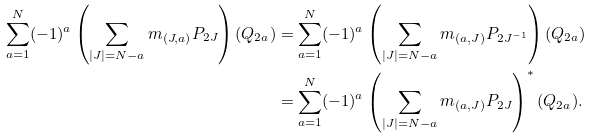Convert formula to latex. <formula><loc_0><loc_0><loc_500><loc_500>\sum _ { a = 1 } ^ { N } ( - 1 ) ^ { a } \left ( \sum _ { | J | = N - a } m _ { ( J , a ) } P _ { 2 J } \right ) ( Q _ { 2 a } ) & = \sum _ { a = 1 } ^ { N } ( - 1 ) ^ { a } \left ( \sum _ { | J | = N - a } m _ { ( a , J ) } P _ { 2 J ^ { - 1 } } \right ) ( Q _ { 2 a } ) \\ & = \sum _ { a = 1 } ^ { N } ( - 1 ) ^ { a } \left ( \sum _ { | J | = N - a } m _ { ( a , J ) } P _ { 2 J } \right ) ^ { * } ( Q _ { 2 a } ) .</formula> 